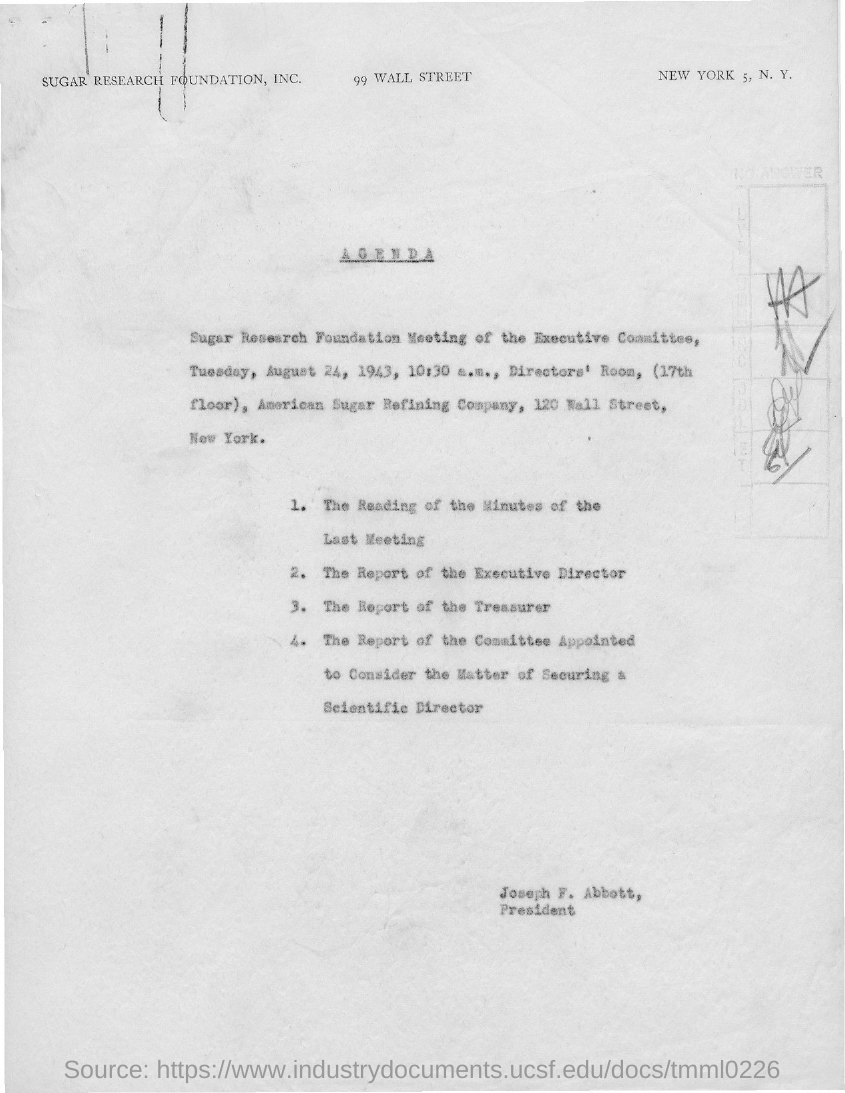What is the name of the foundation as mentioned in the given page ?
Give a very brief answer. Sugar Research Foundation. On which day the meeting was scheduled as given in the agenda ?
Your response must be concise. Tuesday. In which year the meeting was scheduled as mentioned in the given agenda?
Offer a terse response. 1943. What is the name of the company mentioned in the given agenda ?
Give a very brief answer. American Sugar Refining Company. What is the time mentioned in the given agenda ?
Provide a short and direct response. 10:30 a.m. What is the designation of joseph f. abbott as mentioned in the given agenda ?
Ensure brevity in your answer.  President. 